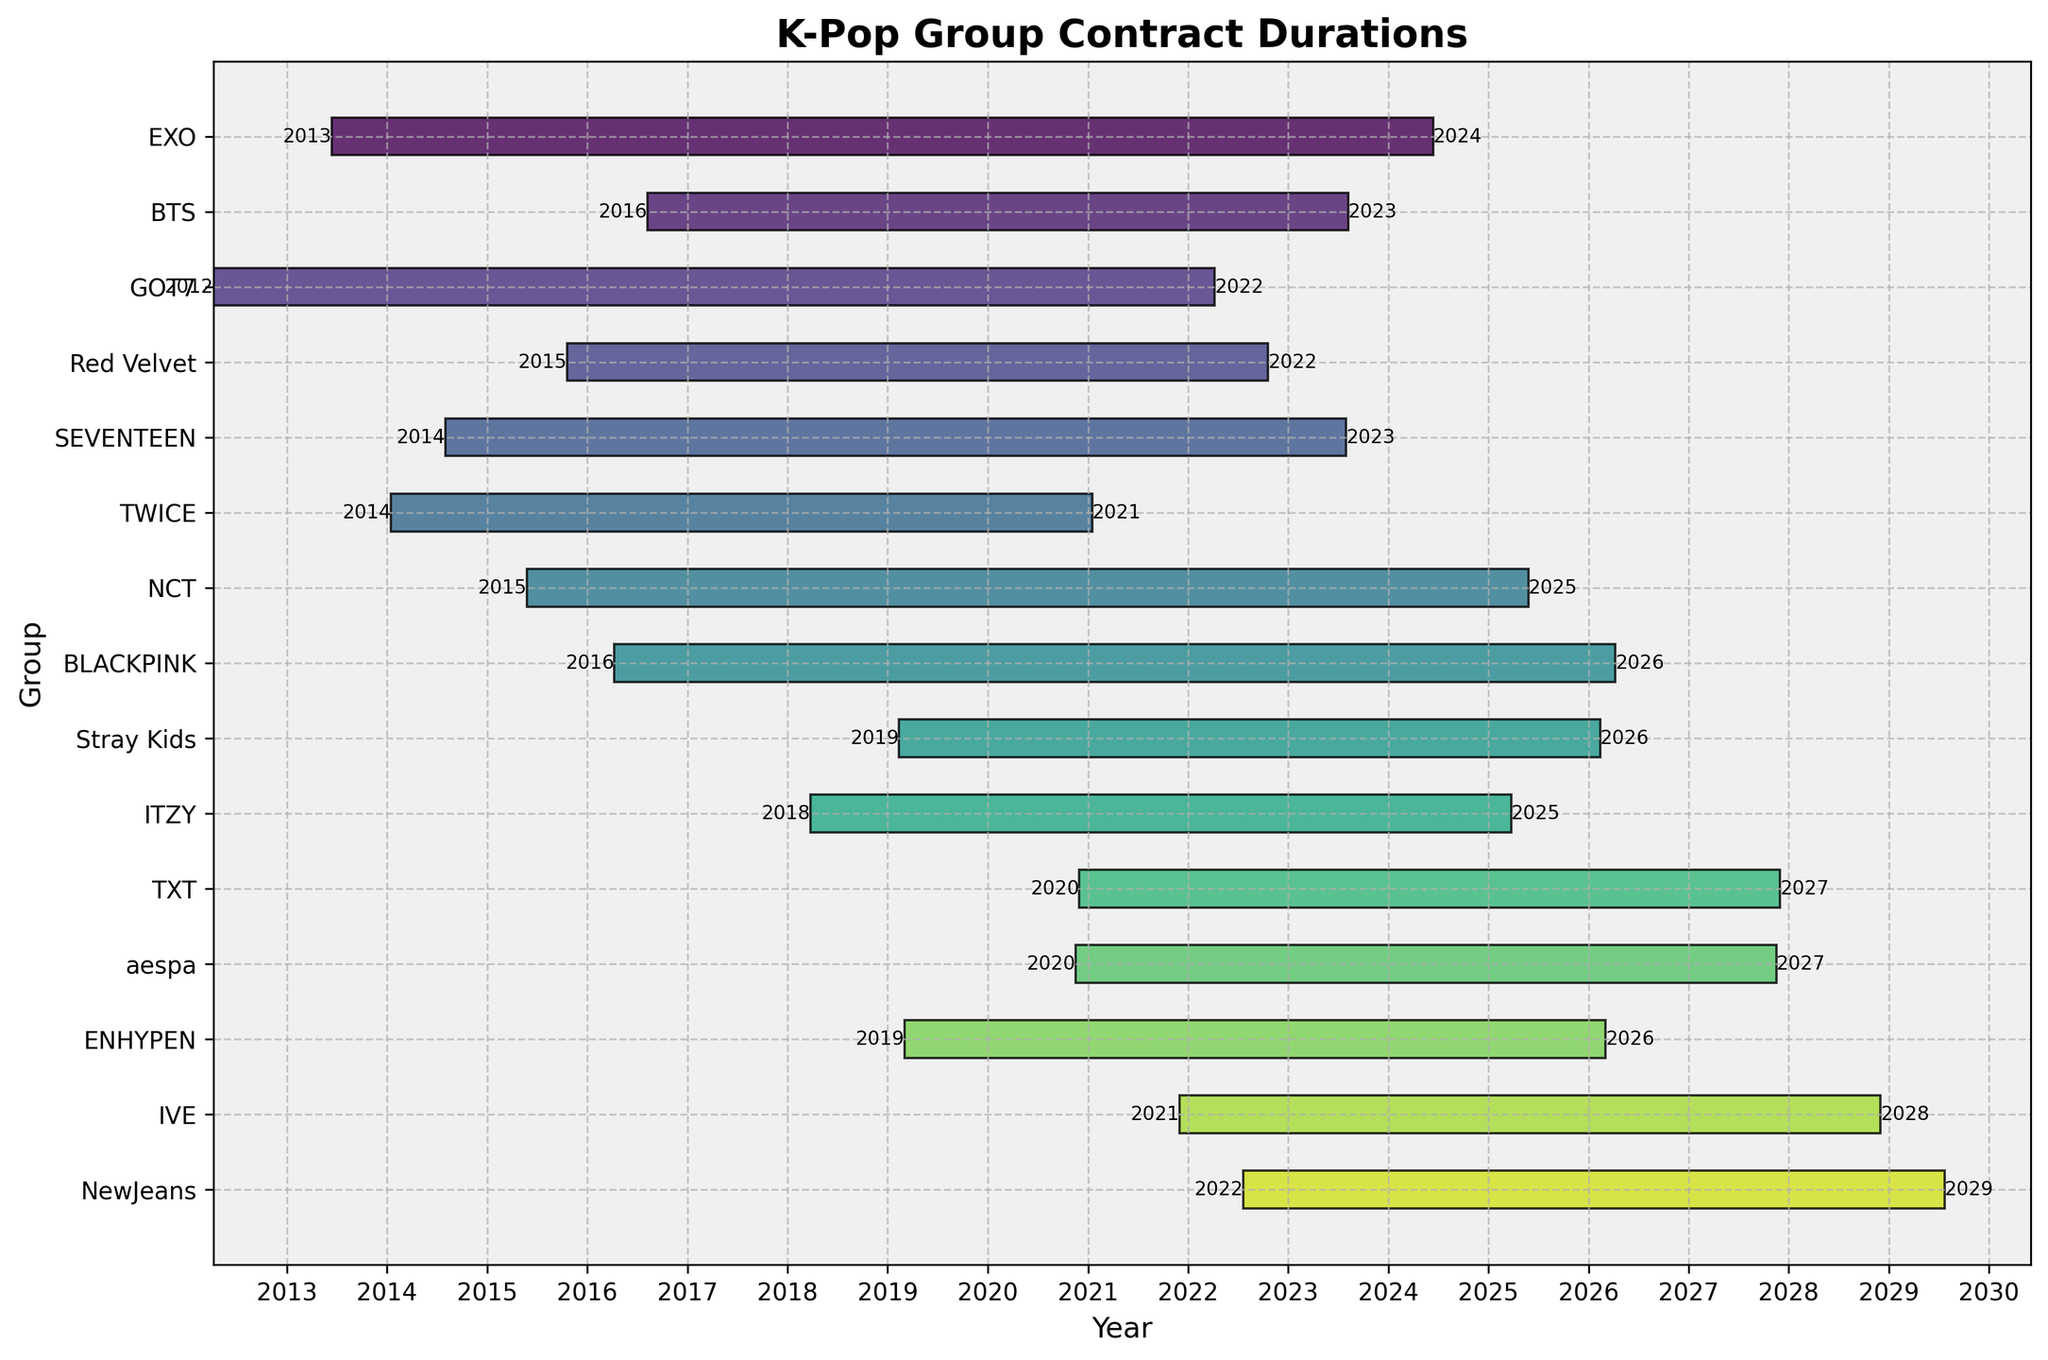what does the title of the figure say? The title of the figure is found at the top and usually summarizes the main topic. Here, it states 'K-Pop Group Contract Durations'.
Answer: K-Pop Group Contract Durations how many K-Pop groups are included in the figure? To determine the number of K-Pop groups, count the unique horizontal bars in the Gantt chart. Each bar represents a group.
Answer: 15 which group has the longest contract duration? To find the longest contract duration, identify the bar that spans the most years from its left to right ends.
Answer: NewJeans between which years does BLACKPINK's contract span? Check the beginning and ending of BLACKPINK's bar. Annotations may highlight the start year and the end year of their contract.
Answer: 2016 to 2023 which two groups have contracts ending in 2026? Look for end dates marked in 2026 and identify the corresponding groups.
Answer: NCT and TXT how many groups had contracts ending in 2022? Count the number of bars that end in the year 2022.
Answer: 2 what is the median debut year of the groups? To find the median debut year, list all start dates, and pick the middle value. Sorted start years are (2012, 2013, 2014, 2014, 2015, 2015, 2016, 2016, 2018, 2019, 2019, 2020, 2020, 2021, 2022). The middle one is 2016.
Answer: 2016 how many years does GOT7's contract last? Subtract the start year from the end year for GOT7's bar to find the duration.
Answer: 7 years which group debuted in 2021 and when does their contract end? Identify the group starting in 2021 and check its corresponding end-year annotation.
Answer: IVE, 2028 which group has a contract that will end first, TWICE or EXO? Compare end years for TWICE and EXO by examining the right ends of their bars.
Answer: EXO 